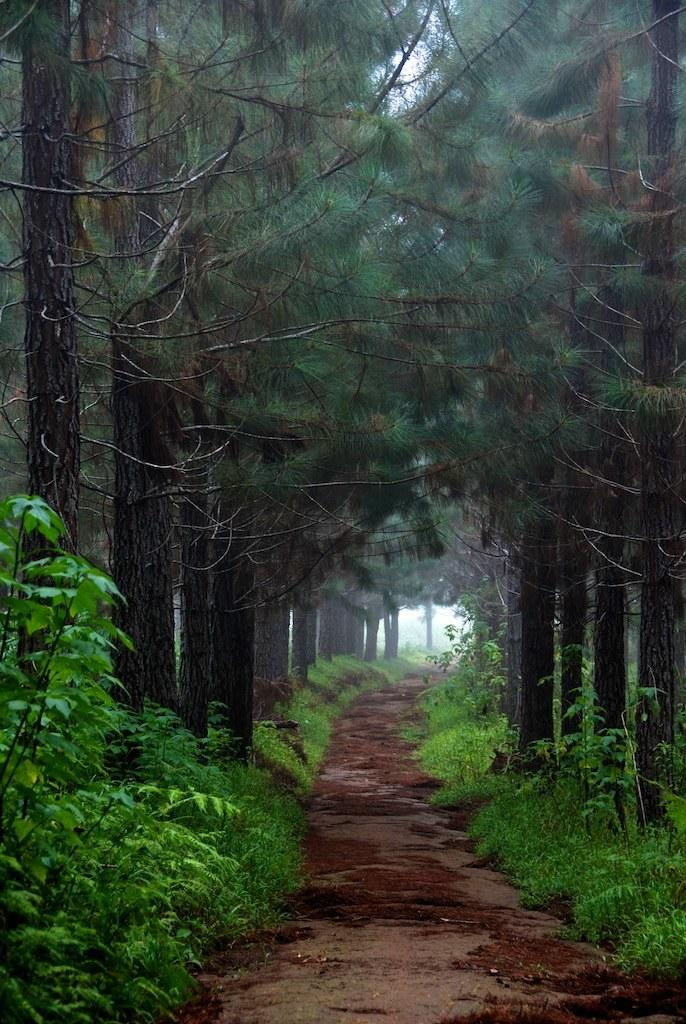Where was the image taken? The image was taken outdoors. What can be seen at the bottom of the image? There is a ground with grass and plants at the bottom of the image. What is visible at the top of the image? There are many trees at the top of the image. What type of print can be seen on the mother's dress in the image? There is no mother or dress present in the image; it features an outdoor scene with grass, plants, and trees. 